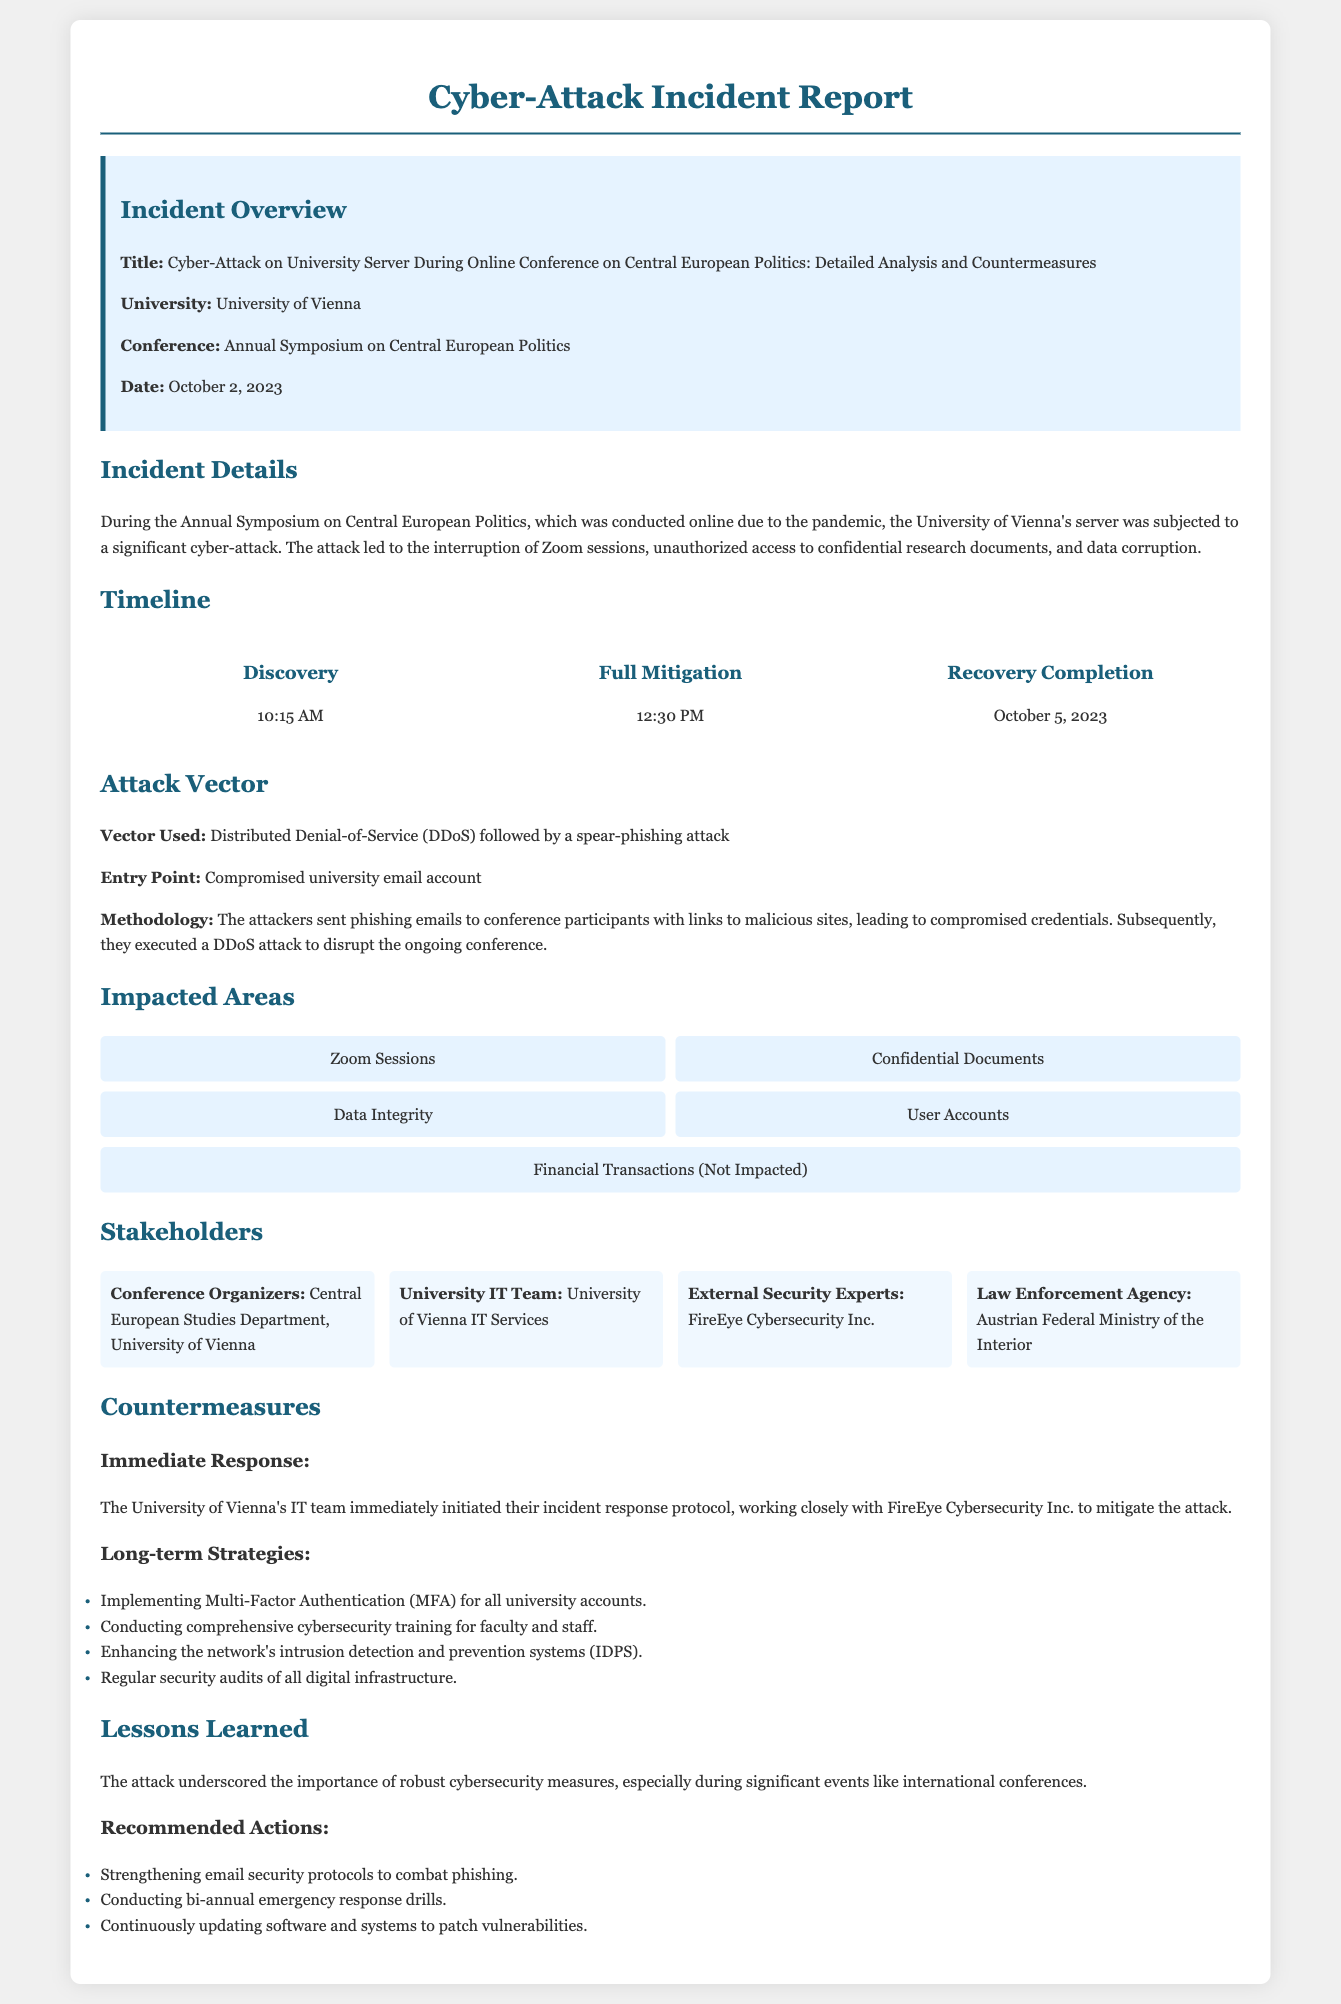What is the title of the incident report? The title is explicitly mentioned in the overview section of the document.
Answer: Cyber-Attack on University Server During Online Conference on Central European Politics: Detailed Analysis and Countermeasures What university is involved in the incident? The university name is highlighted in the overview section, identifying the institution affected.
Answer: University of Vienna What was the date of the cyber-attack? The date is explicitly stated in the incident overview section.
Answer: October 2, 2023 What attack vector was used in the incident? The document clearly specifies the type of attack vector utilized in the incident.
Answer: Distributed Denial-of-Service (DDoS) followed by a spear-phishing attack Who aided the University of Vienna's IT team during the mitigation process? This information is provided in the countermeasures section, highlighting collaboration.
Answer: FireEye Cybersecurity Inc What was the entry point for the attackers? The document outlines how the attackers gained access through a specific vulnerability.
Answer: Compromised university email account What is one of the long-term strategies recommended in the report? The report lists several long-term strategies in the countermeasures section.
Answer: Implementing Multi-Factor Authentication (MFA) for all university accounts What time was the cyber-attack discovered? The timeline section of the document precisely notes the discovery time.
Answer: 10:15 AM What was the completion date for recovery after the attack? The timeline section includes the date when recovery efforts were concluded.
Answer: October 5, 2023 